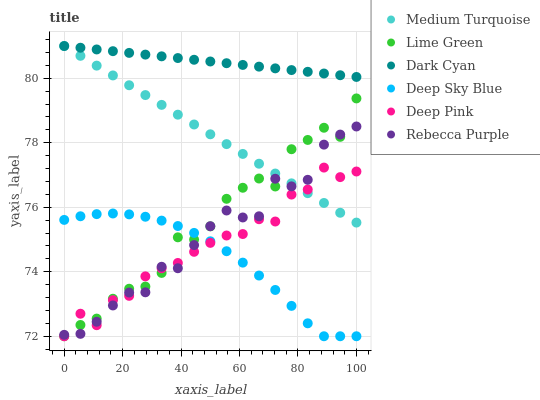Does Deep Sky Blue have the minimum area under the curve?
Answer yes or no. Yes. Does Dark Cyan have the maximum area under the curve?
Answer yes or no. Yes. Does Medium Turquoise have the minimum area under the curve?
Answer yes or no. No. Does Medium Turquoise have the maximum area under the curve?
Answer yes or no. No. Is Dark Cyan the smoothest?
Answer yes or no. Yes. Is Lime Green the roughest?
Answer yes or no. Yes. Is Medium Turquoise the smoothest?
Answer yes or no. No. Is Medium Turquoise the roughest?
Answer yes or no. No. Does Deep Pink have the lowest value?
Answer yes or no. Yes. Does Medium Turquoise have the lowest value?
Answer yes or no. No. Does Dark Cyan have the highest value?
Answer yes or no. Yes. Does Rebecca Purple have the highest value?
Answer yes or no. No. Is Lime Green less than Dark Cyan?
Answer yes or no. Yes. Is Dark Cyan greater than Lime Green?
Answer yes or no. Yes. Does Deep Sky Blue intersect Rebecca Purple?
Answer yes or no. Yes. Is Deep Sky Blue less than Rebecca Purple?
Answer yes or no. No. Is Deep Sky Blue greater than Rebecca Purple?
Answer yes or no. No. Does Lime Green intersect Dark Cyan?
Answer yes or no. No. 